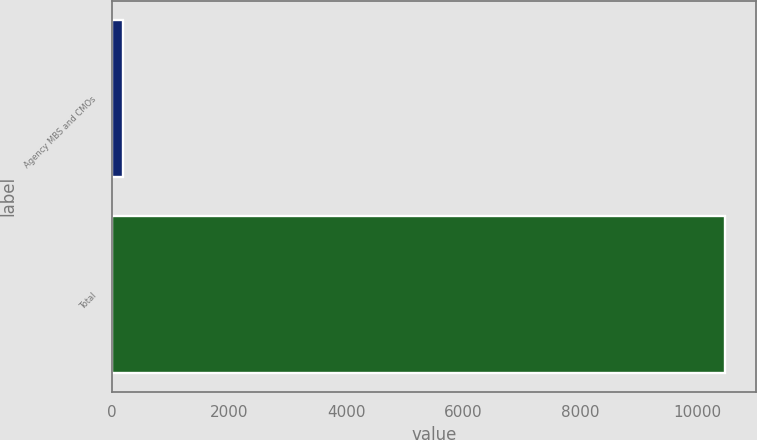Convert chart. <chart><loc_0><loc_0><loc_500><loc_500><bar_chart><fcel>Agency MBS and CMOs<fcel>Total<nl><fcel>193<fcel>10472<nl></chart> 